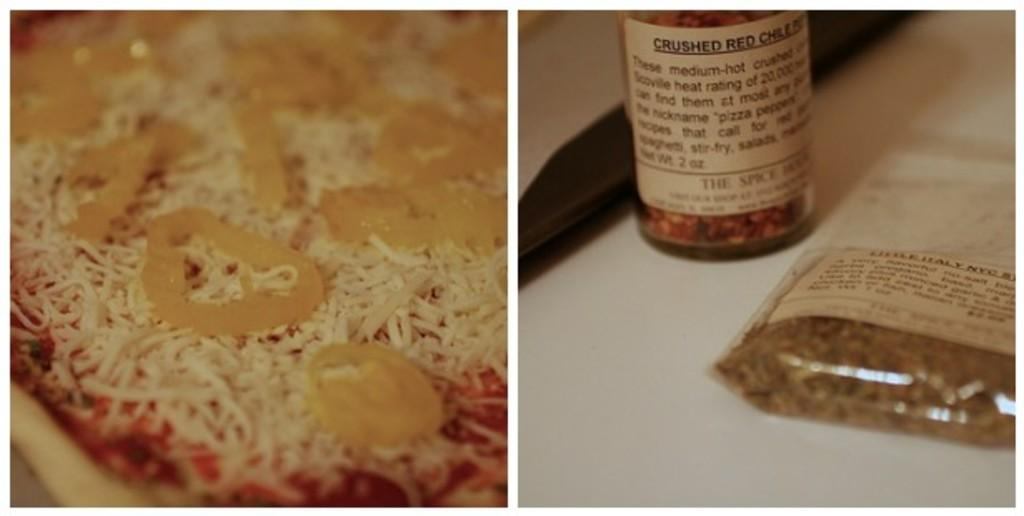What is located on the right side of the image? There is a bottle and a packet on the right side of the image. What else can be seen in the image besides the bottle and packet? There is a pizza in the image. What type of topping is on the pizza? The pizza has cheese on it. What type of destruction can be seen happening to the pizza in the image? There is no destruction happening to the pizza in the image; it appears to be intact with cheese on it. 